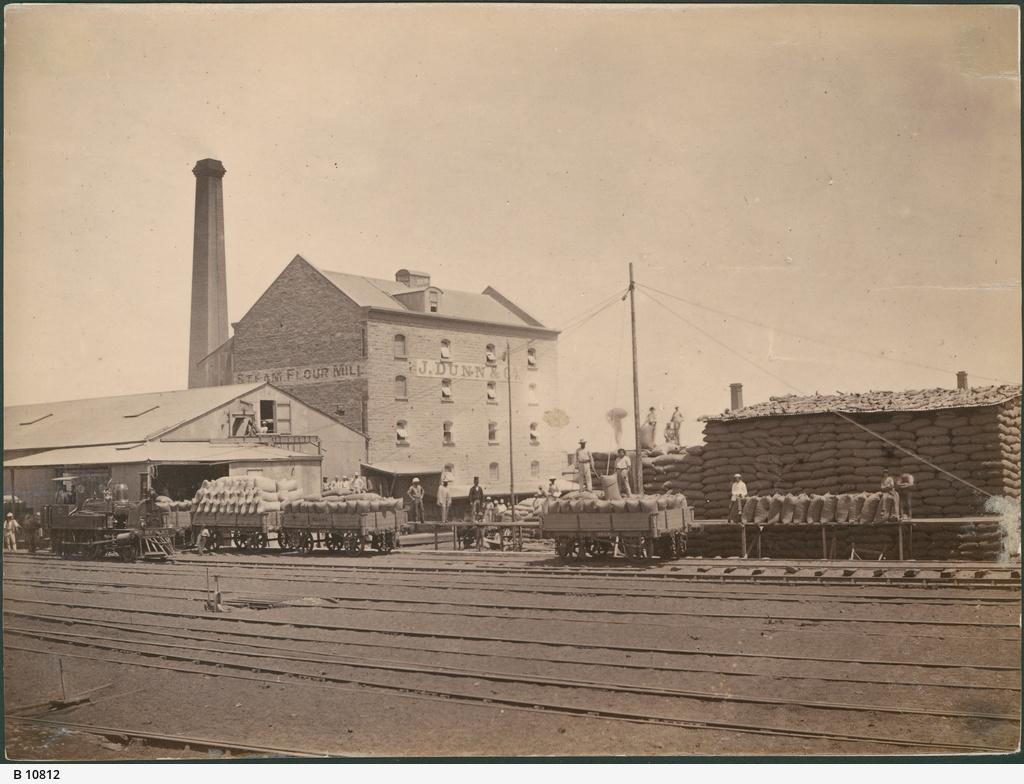What animals are present in the image? There are bats in the image. How are the bats being transported? The bats are in carts. Who else is present in the image besides the bats? There are people in the image. What objects can be seen in the image that might be used for carrying items? There are bags in the image. What structures can be seen in the background of the image? There is a building, a shed, and a pole with wires in the background of the image. What part of the natural environment is visible in the image? The sky is visible in the background of the image. What type of station is depicted in the image? There is no station present in the image. How many people are playing in the park in the image? There is no park or people playing in the image; it features bats in carts with people nearby. 